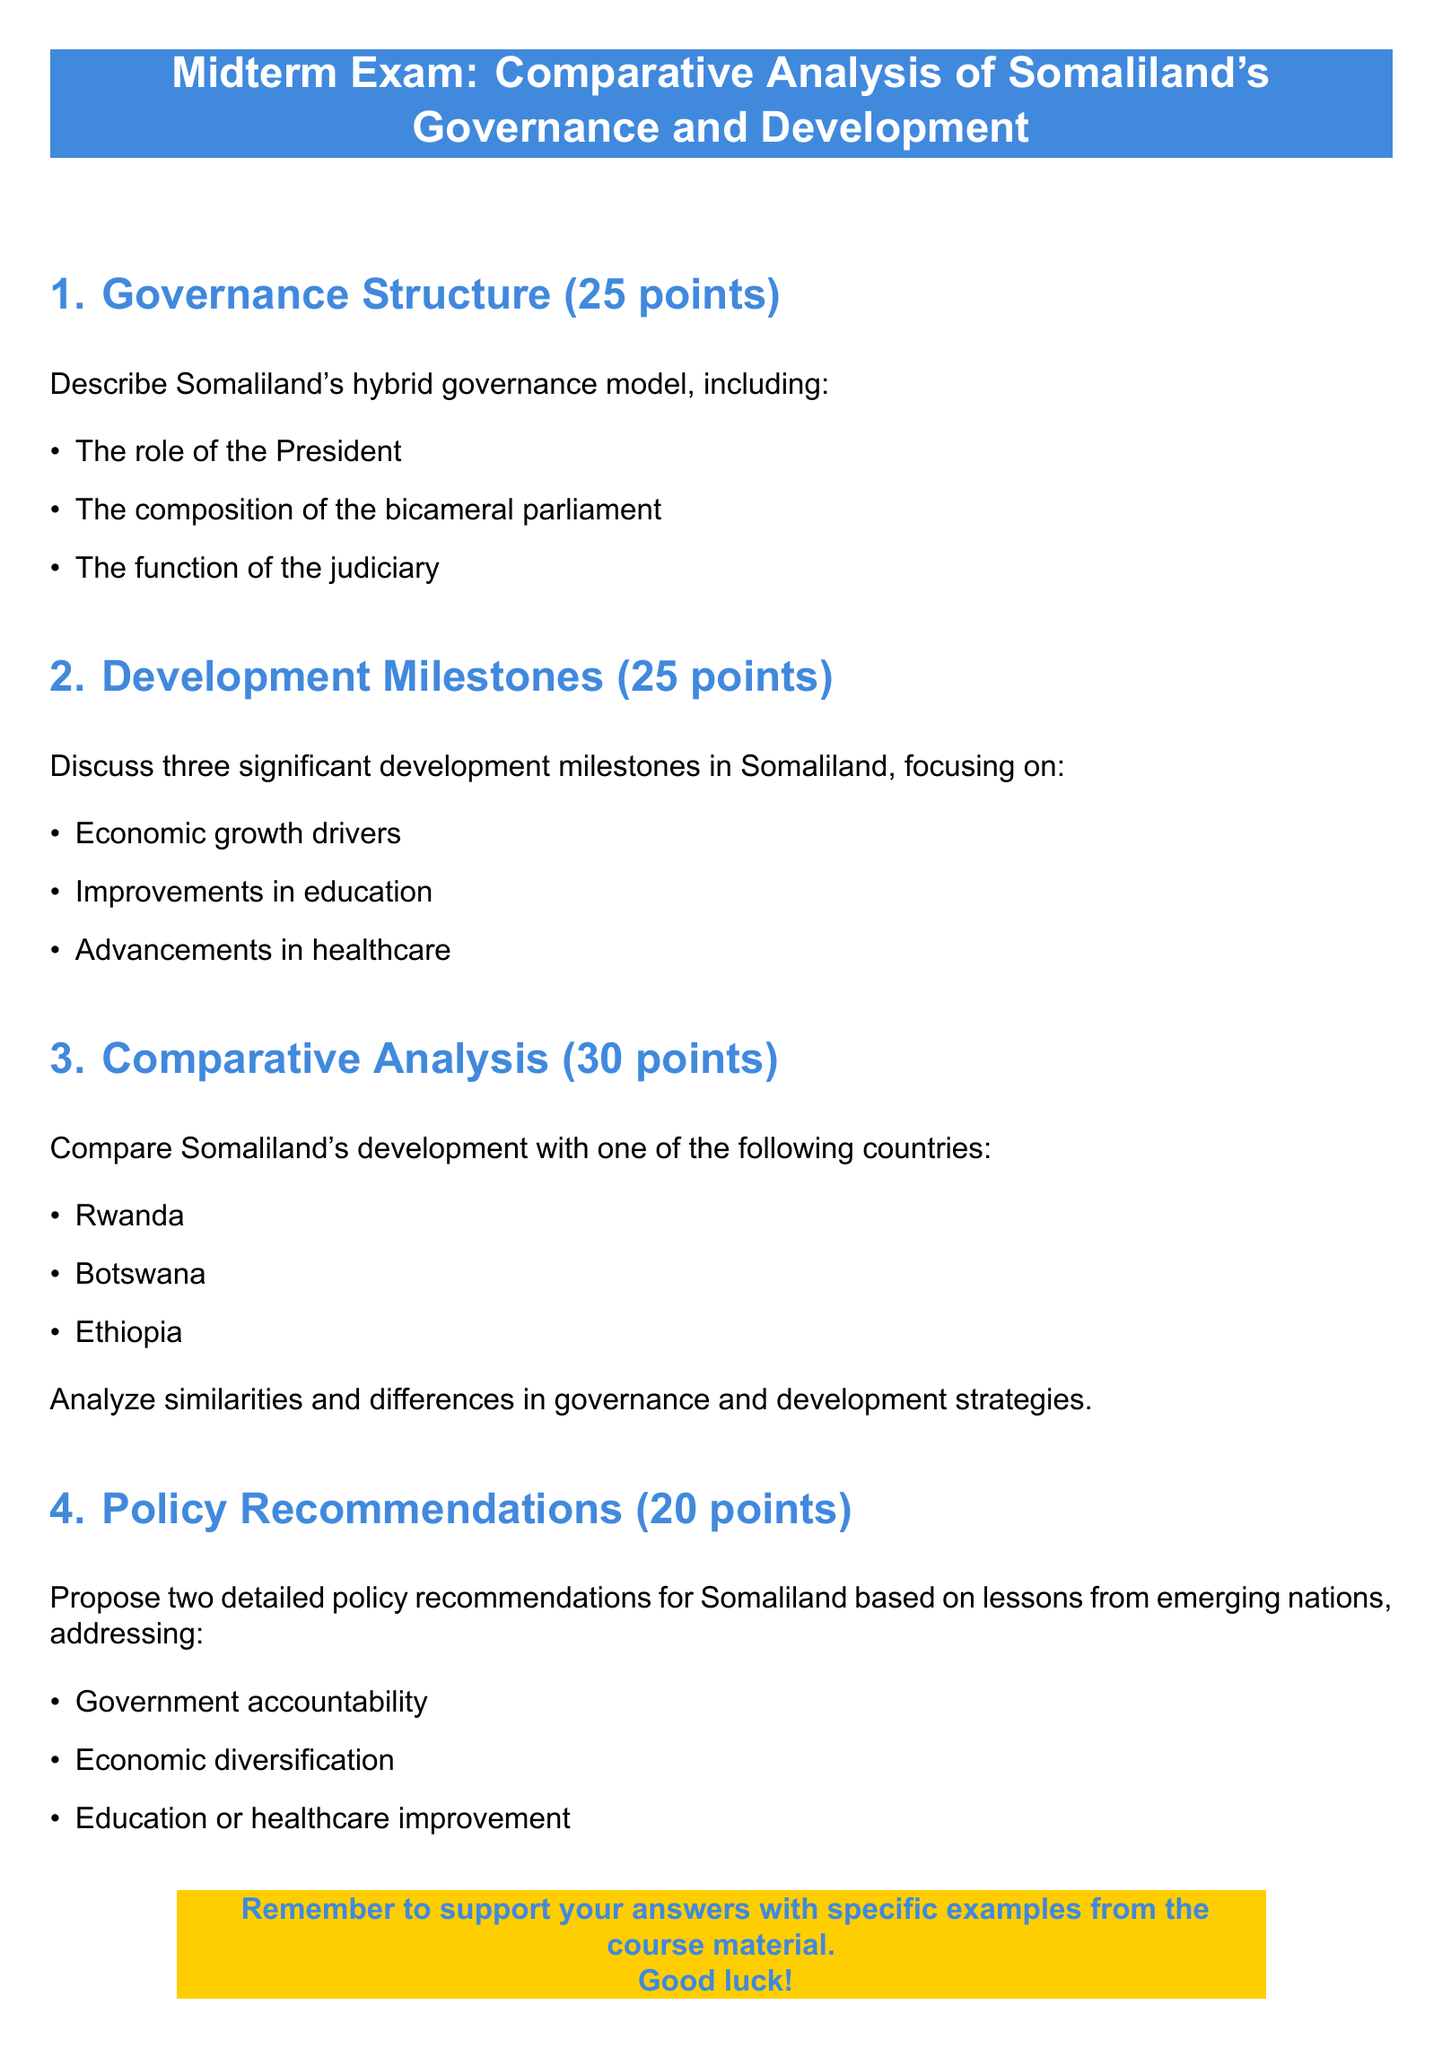What is the total number of points for the Governance Structure section? The document states that the Governance Structure section is worth 25 points.
Answer: 25 points Who are the three countries listed for comparative analysis? The document lists Rwanda, Botswana, and Ethiopia for comparative analysis.
Answer: Rwanda, Botswana, Ethiopia How many points is the Policy Recommendations section worth? The document specifies that the Policy Recommendations section is worth 20 points.
Answer: 20 points What are the two topics addressed in the Policy Recommendations? The document mentions government accountability and economic diversification as topics.
Answer: Government accountability, economic diversification What color is used for the exam header? The document uses somaliblue for the exam header.
Answer: Somaliblue What type of governance model does Somaliland have? The document describes Somaliland's governance model as a hybrid model.
Answer: Hybrid model How many significant development milestones are discussed in the Development Milestones section? The document states that three significant development milestones are discussed in this section.
Answer: Three What specific examples should be included in the answers? The document advises to support answers with specific examples from the course material.
Answer: Specific examples from the course material What is the font used in the document? The document specifies that the main font used is Arial.
Answer: Arial 